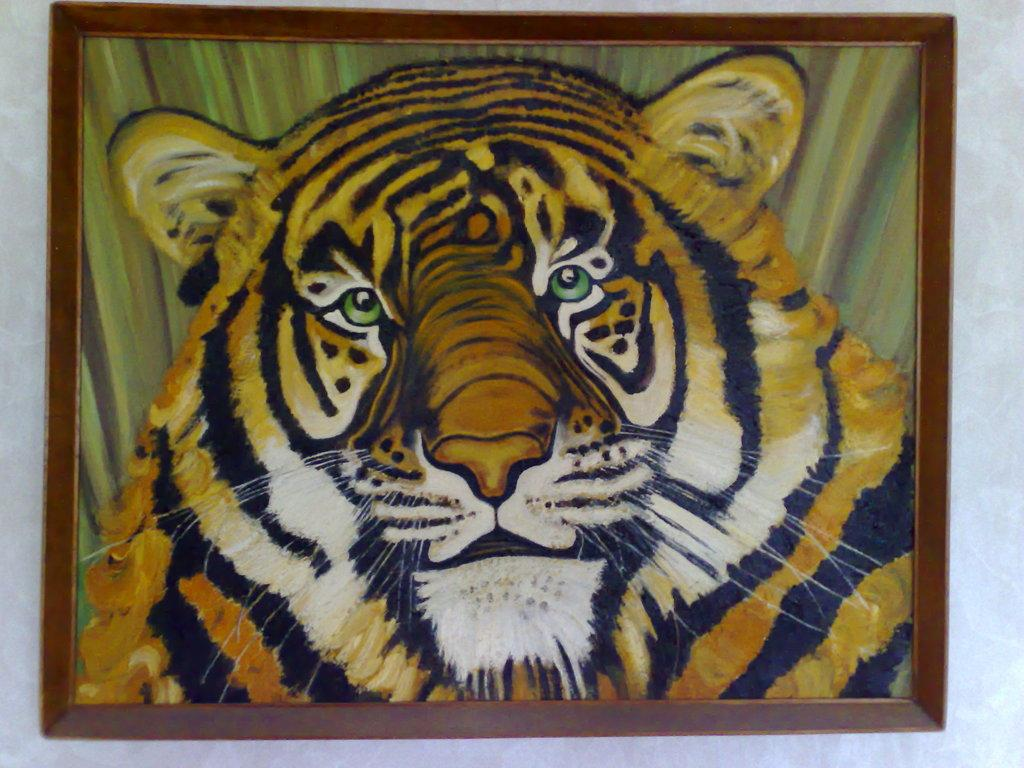What is the main subject of the image? The main subject of the image is a tiger's face. How is the tiger's face presented in the image? The tiger's face is within a frame in the image. What type of muscle can be seen in the image? There is no muscle visible in the image; it features a tiger's face within a frame. Where was the tiger born in the image? The image does not provide information about the tiger's birth or location. 